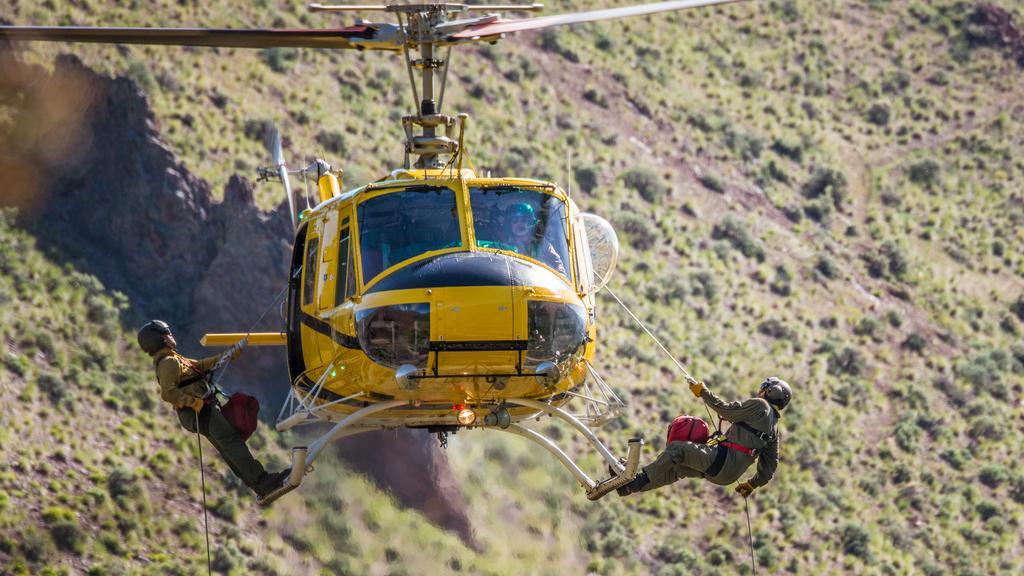In one or two sentences, can you explain what this image depicts? In this image I can see two men are tied up with a rope to a helicopter. These men are wearing helmet and other objects. The helicopter is yellow in color. In the background I can see plants. 